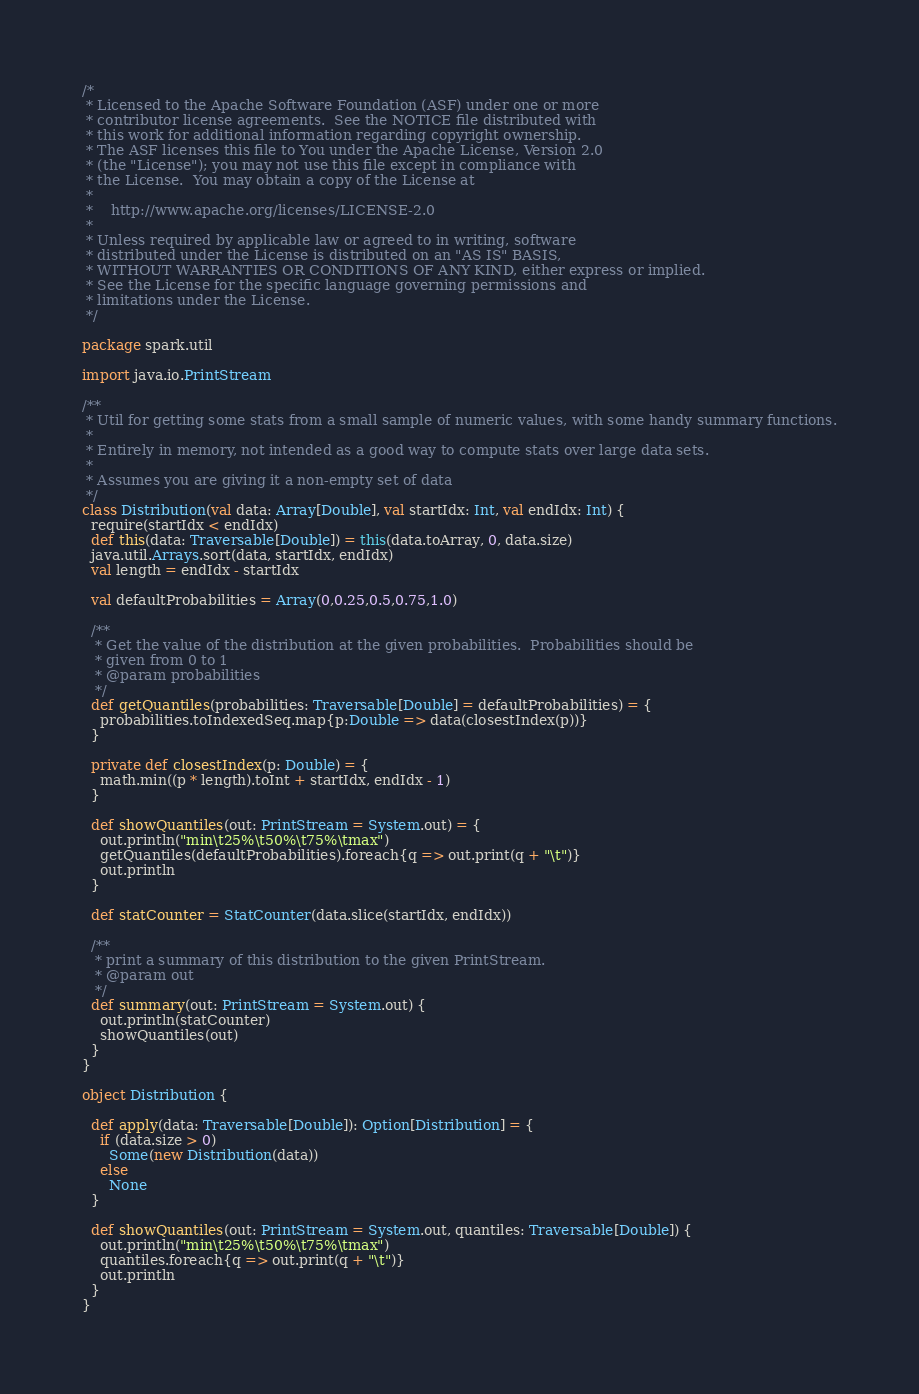Convert code to text. <code><loc_0><loc_0><loc_500><loc_500><_Scala_>/*
 * Licensed to the Apache Software Foundation (ASF) under one or more
 * contributor license agreements.  See the NOTICE file distributed with
 * this work for additional information regarding copyright ownership.
 * The ASF licenses this file to You under the Apache License, Version 2.0
 * (the "License"); you may not use this file except in compliance with
 * the License.  You may obtain a copy of the License at
 *
 *    http://www.apache.org/licenses/LICENSE-2.0
 *
 * Unless required by applicable law or agreed to in writing, software
 * distributed under the License is distributed on an "AS IS" BASIS,
 * WITHOUT WARRANTIES OR CONDITIONS OF ANY KIND, either express or implied.
 * See the License for the specific language governing permissions and
 * limitations under the License.
 */

package spark.util

import java.io.PrintStream

/**
 * Util for getting some stats from a small sample of numeric values, with some handy summary functions.
 *
 * Entirely in memory, not intended as a good way to compute stats over large data sets.
 *
 * Assumes you are giving it a non-empty set of data
 */
class Distribution(val data: Array[Double], val startIdx: Int, val endIdx: Int) {
  require(startIdx < endIdx)
  def this(data: Traversable[Double]) = this(data.toArray, 0, data.size)
  java.util.Arrays.sort(data, startIdx, endIdx)
  val length = endIdx - startIdx

  val defaultProbabilities = Array(0,0.25,0.5,0.75,1.0)

  /**
   * Get the value of the distribution at the given probabilities.  Probabilities should be
   * given from 0 to 1
   * @param probabilities
   */
  def getQuantiles(probabilities: Traversable[Double] = defaultProbabilities) = {
    probabilities.toIndexedSeq.map{p:Double => data(closestIndex(p))}
  }

  private def closestIndex(p: Double) = {
    math.min((p * length).toInt + startIdx, endIdx - 1)
  }

  def showQuantiles(out: PrintStream = System.out) = {
    out.println("min\t25%\t50%\t75%\tmax")
    getQuantiles(defaultProbabilities).foreach{q => out.print(q + "\t")}
    out.println
  }

  def statCounter = StatCounter(data.slice(startIdx, endIdx))

  /**
   * print a summary of this distribution to the given PrintStream.
   * @param out
   */
  def summary(out: PrintStream = System.out) {
    out.println(statCounter)
    showQuantiles(out)
  }
}

object Distribution {

  def apply(data: Traversable[Double]): Option[Distribution] = {
    if (data.size > 0)
      Some(new Distribution(data))
    else
      None
  }

  def showQuantiles(out: PrintStream = System.out, quantiles: Traversable[Double]) {
    out.println("min\t25%\t50%\t75%\tmax")
    quantiles.foreach{q => out.print(q + "\t")}
    out.println
  }
}
</code> 